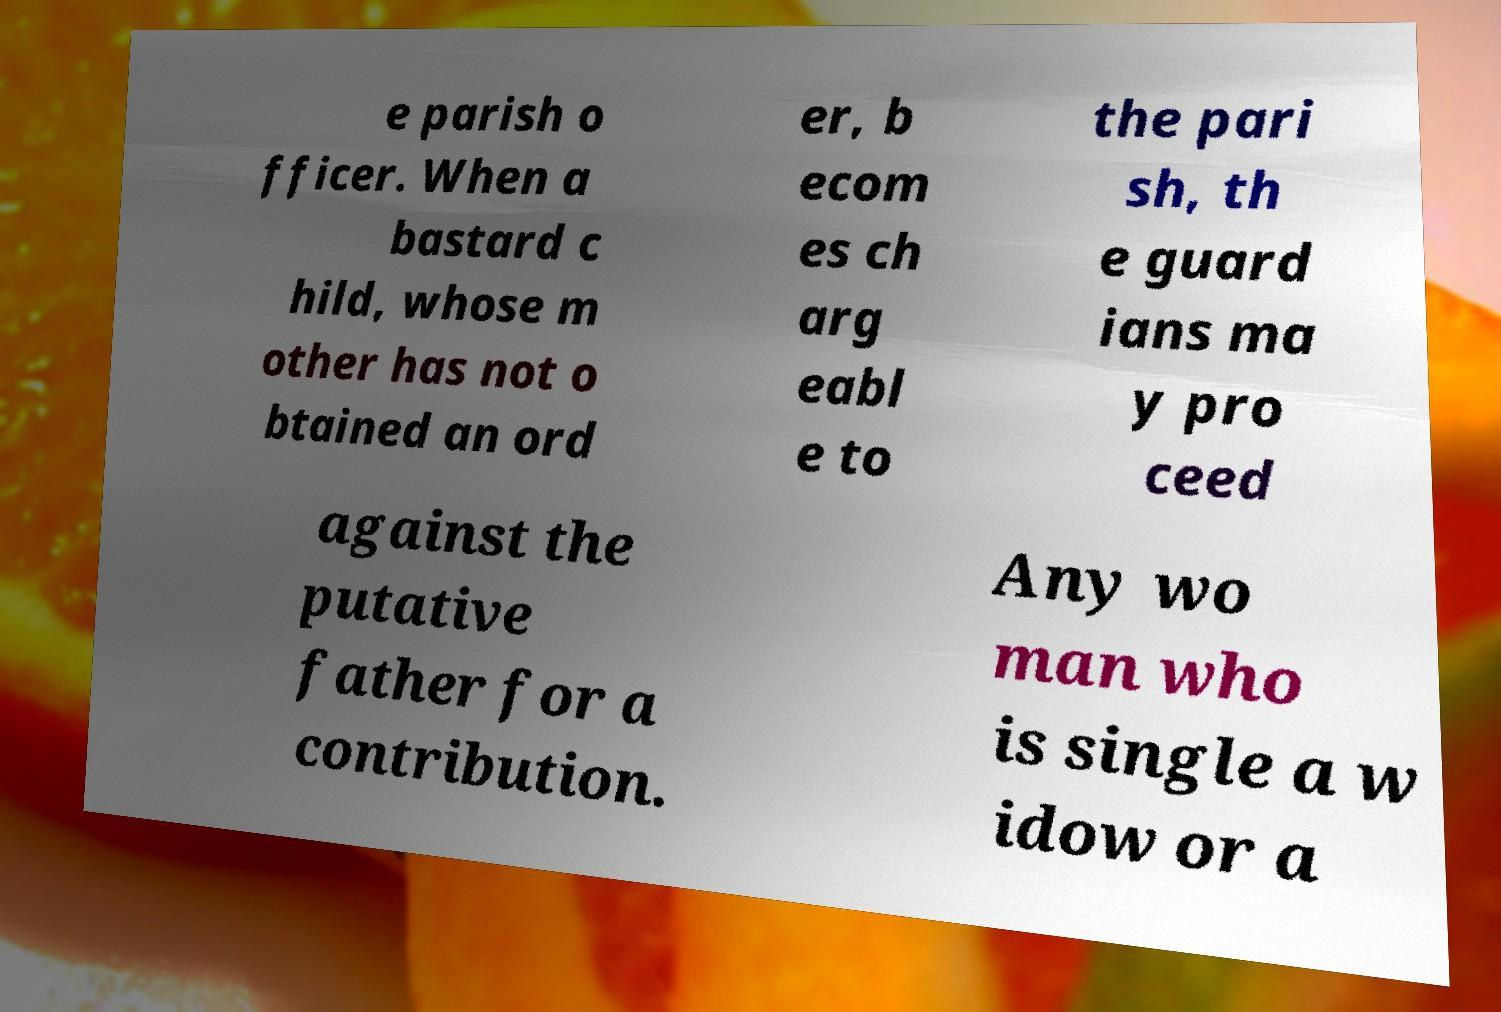Can you accurately transcribe the text from the provided image for me? e parish o fficer. When a bastard c hild, whose m other has not o btained an ord er, b ecom es ch arg eabl e to the pari sh, th e guard ians ma y pro ceed against the putative father for a contribution. Any wo man who is single a w idow or a 